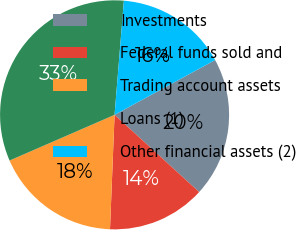Convert chart to OTSL. <chart><loc_0><loc_0><loc_500><loc_500><pie_chart><fcel>Investments<fcel>Federal funds sold and<fcel>Trading account assets<fcel>Loans (1)<fcel>Other financial assets (2)<nl><fcel>19.72%<fcel>13.86%<fcel>17.83%<fcel>32.83%<fcel>15.76%<nl></chart> 